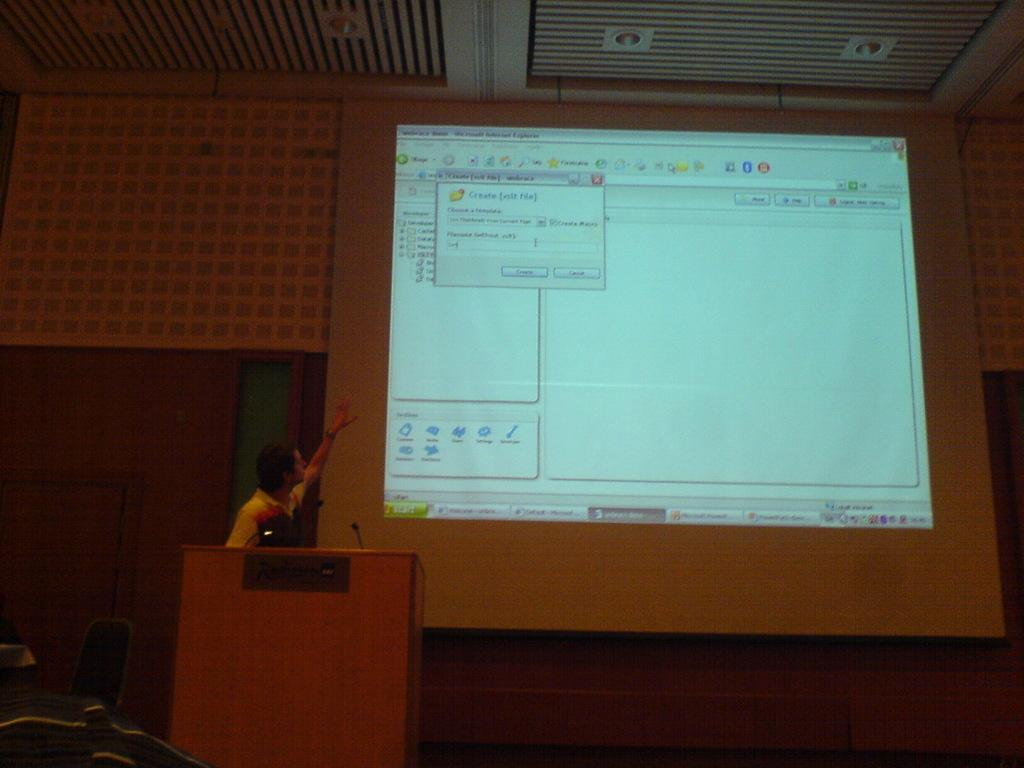<image>
Present a compact description of the photo's key features. A presentation about how to create a new folder is displayed on a projector screen. 